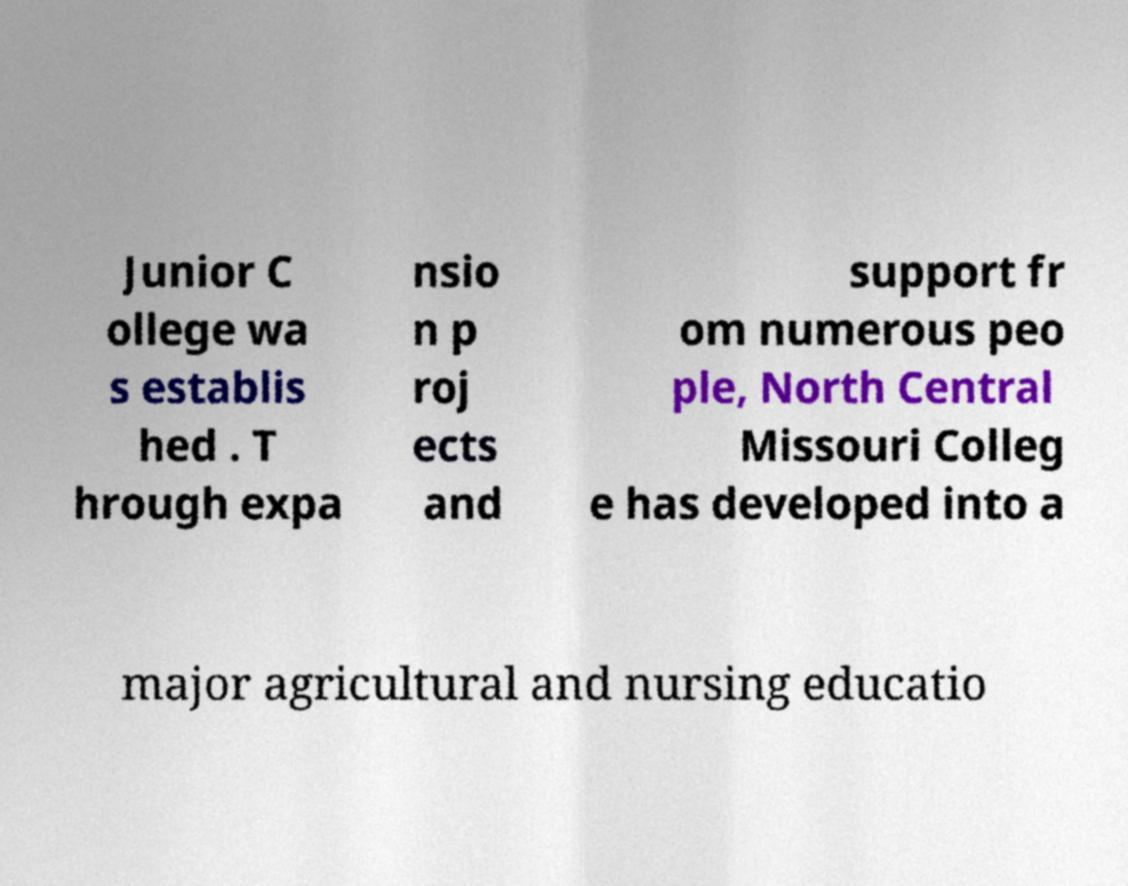What messages or text are displayed in this image? I need them in a readable, typed format. Junior C ollege wa s establis hed . T hrough expa nsio n p roj ects and support fr om numerous peo ple, North Central Missouri Colleg e has developed into a major agricultural and nursing educatio 